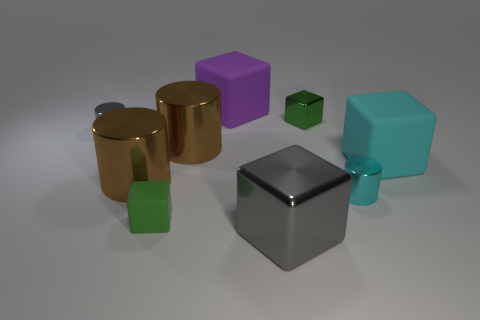Subtract all gray shiny cylinders. How many cylinders are left? 3 Add 1 big gray things. How many objects exist? 10 Subtract all blue balls. How many green blocks are left? 2 Subtract all brown cylinders. How many cylinders are left? 2 Subtract all cylinders. How many objects are left? 5 Add 4 large red metal spheres. How many large red metal spheres exist? 4 Subtract 0 red spheres. How many objects are left? 9 Subtract 1 cubes. How many cubes are left? 4 Subtract all brown cubes. Subtract all green spheres. How many cubes are left? 5 Subtract all red metal spheres. Subtract all large metal cylinders. How many objects are left? 7 